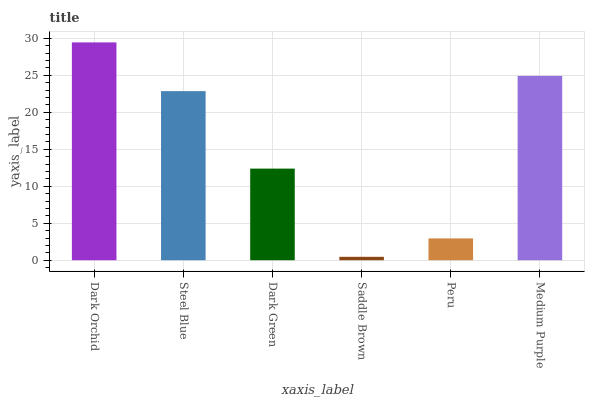Is Saddle Brown the minimum?
Answer yes or no. Yes. Is Dark Orchid the maximum?
Answer yes or no. Yes. Is Steel Blue the minimum?
Answer yes or no. No. Is Steel Blue the maximum?
Answer yes or no. No. Is Dark Orchid greater than Steel Blue?
Answer yes or no. Yes. Is Steel Blue less than Dark Orchid?
Answer yes or no. Yes. Is Steel Blue greater than Dark Orchid?
Answer yes or no. No. Is Dark Orchid less than Steel Blue?
Answer yes or no. No. Is Steel Blue the high median?
Answer yes or no. Yes. Is Dark Green the low median?
Answer yes or no. Yes. Is Medium Purple the high median?
Answer yes or no. No. Is Peru the low median?
Answer yes or no. No. 